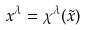<formula> <loc_0><loc_0><loc_500><loc_500>x ^ { \lambda } = \chi ^ { \lambda } ( \tilde { x } )</formula> 